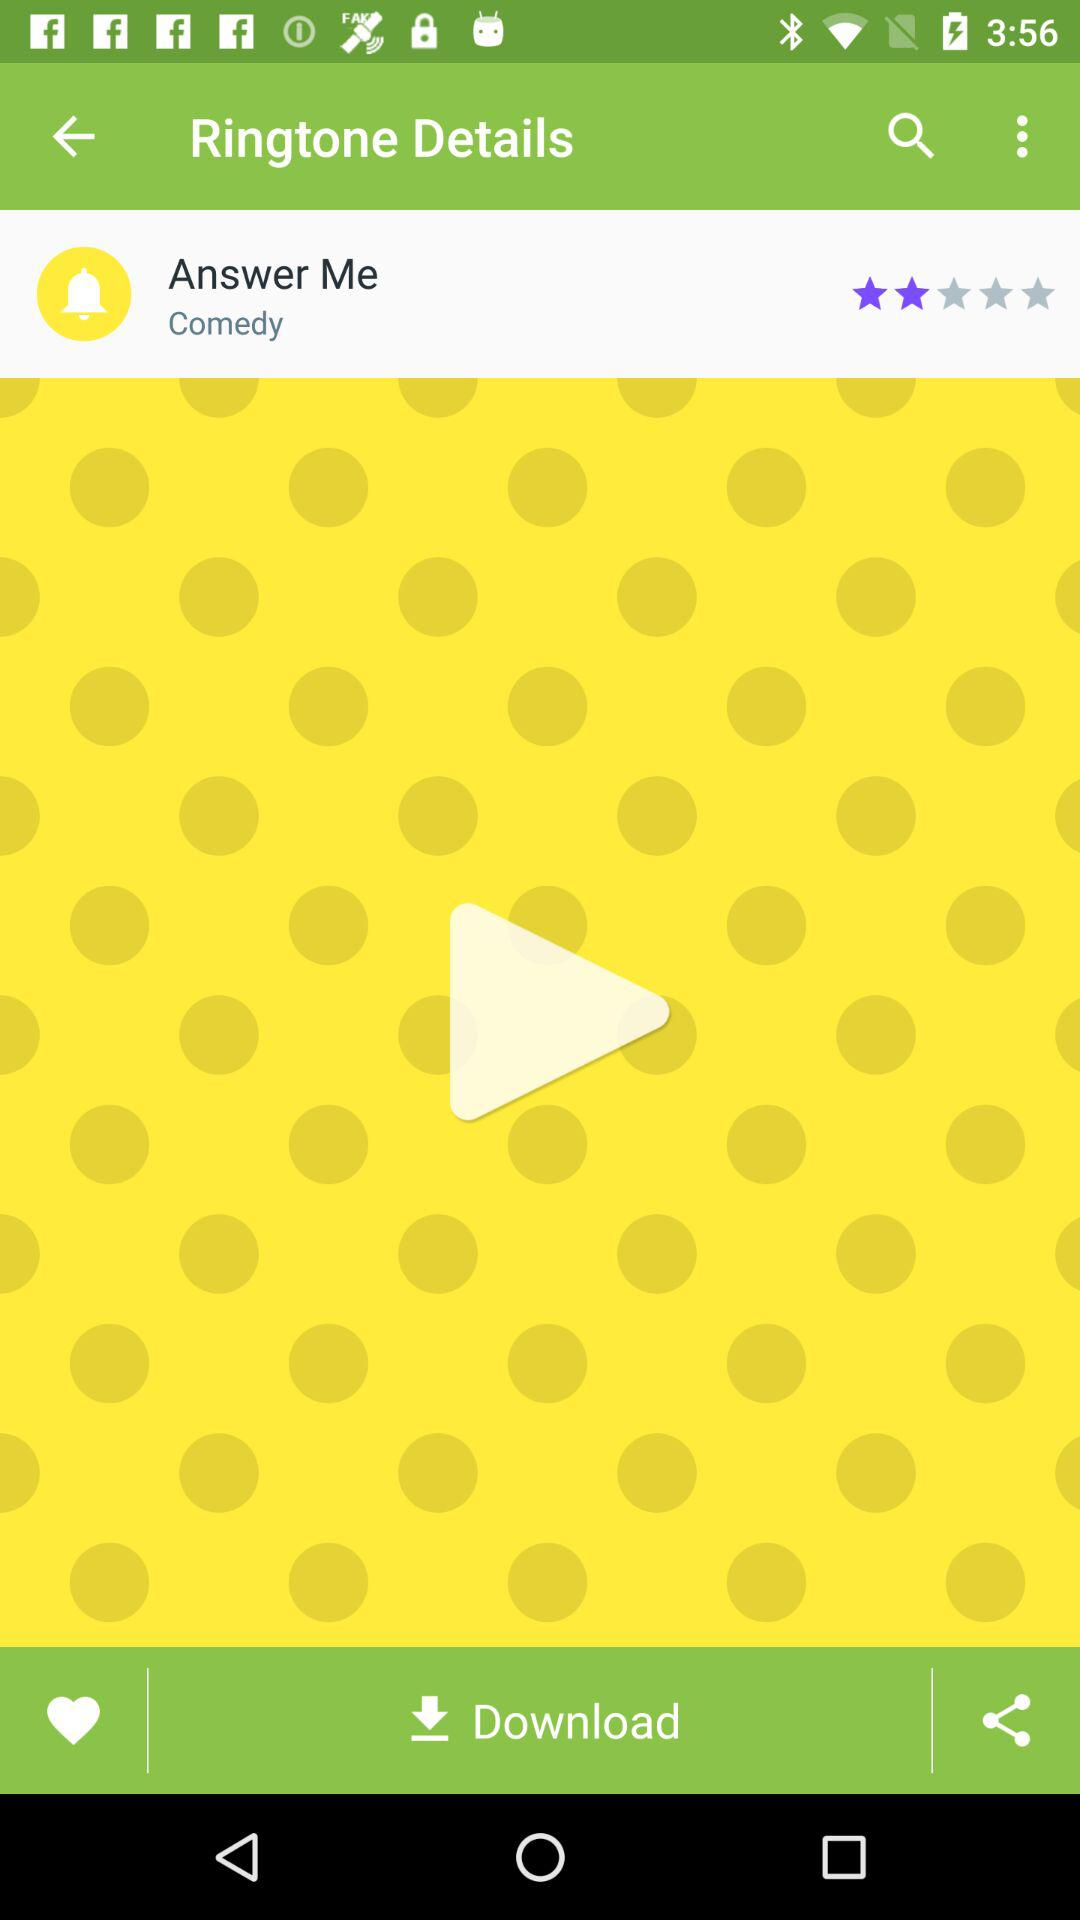What is the rating of the Answer Me ringtone? The rating is 2 stars. 